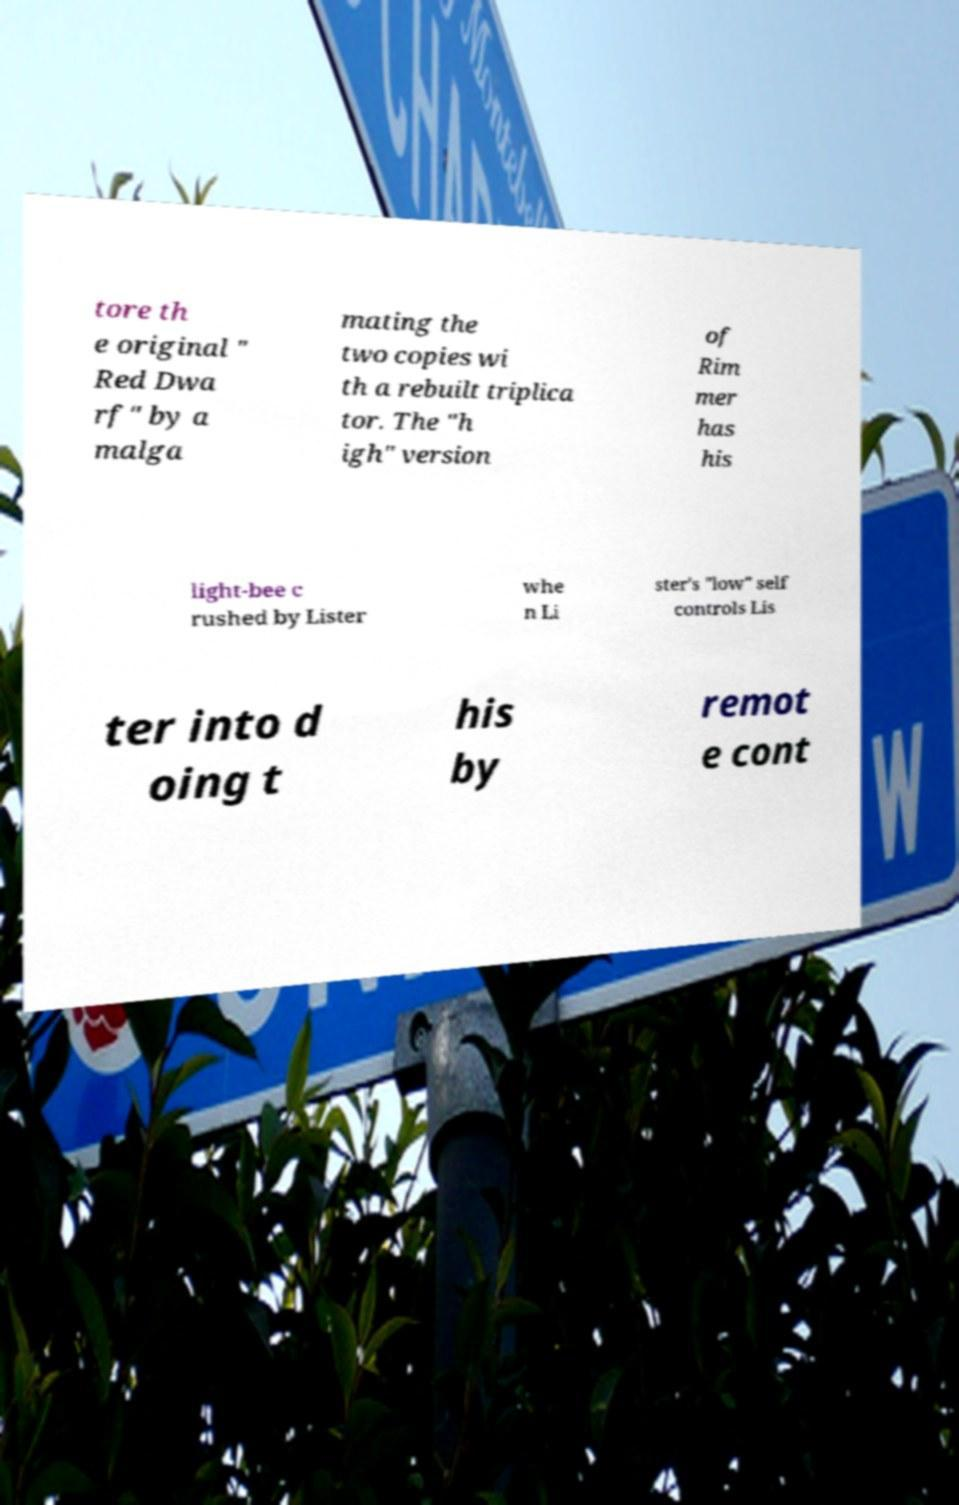Could you assist in decoding the text presented in this image and type it out clearly? tore th e original " Red Dwa rf" by a malga mating the two copies wi th a rebuilt triplica tor. The "h igh" version of Rim mer has his light-bee c rushed by Lister whe n Li ster's "low" self controls Lis ter into d oing t his by remot e cont 